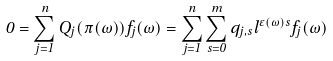<formula> <loc_0><loc_0><loc_500><loc_500>0 = \sum _ { j = 1 } ^ { n } Q _ { j } ( \pi ( \omega ) ) f _ { j } ( \omega ) = \sum _ { j = 1 } ^ { n } \sum _ { s = 0 } ^ { m } q _ { j , s } l ^ { \varepsilon ( \omega ) s } f _ { j } ( \omega )</formula> 